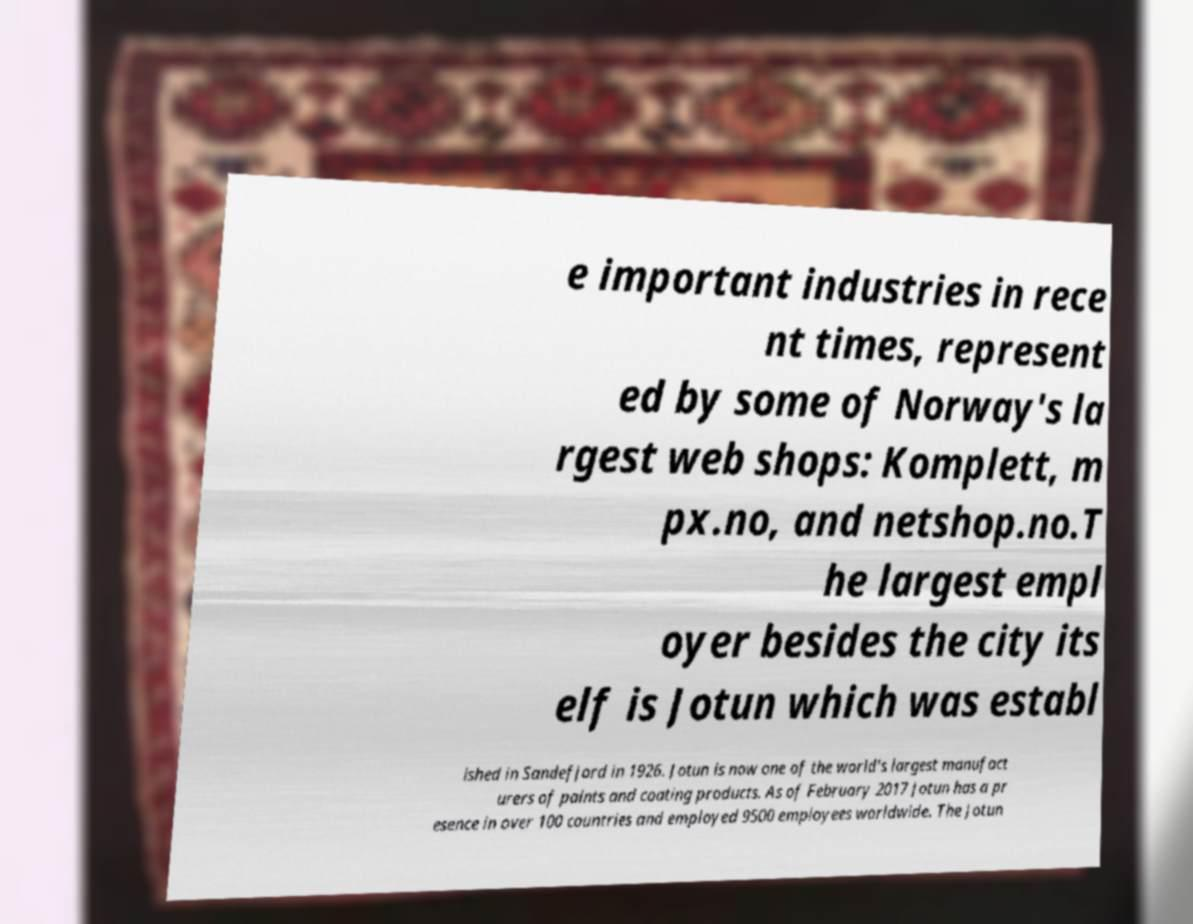Can you accurately transcribe the text from the provided image for me? e important industries in rece nt times, represent ed by some of Norway's la rgest web shops: Komplett, m px.no, and netshop.no.T he largest empl oyer besides the city its elf is Jotun which was establ ished in Sandefjord in 1926. Jotun is now one of the world's largest manufact urers of paints and coating products. As of February 2017 Jotun has a pr esence in over 100 countries and employed 9500 employees worldwide. The Jotun 